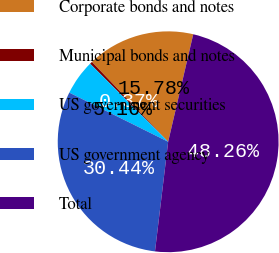Convert chart. <chart><loc_0><loc_0><loc_500><loc_500><pie_chart><fcel>Corporate bonds and notes<fcel>Municipal bonds and notes<fcel>US government securities<fcel>US government agency<fcel>Total<nl><fcel>15.78%<fcel>0.37%<fcel>5.16%<fcel>30.44%<fcel>48.26%<nl></chart> 